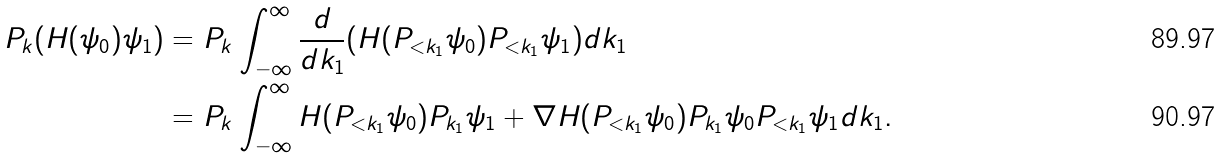<formula> <loc_0><loc_0><loc_500><loc_500>P _ { k } ( H ( \psi _ { 0 } ) \psi _ { 1 } ) = & \ P _ { k } \int _ { - \infty } ^ { \infty } \frac { d } { d k _ { 1 } } ( H ( P _ { < k _ { 1 } } \psi _ { 0 } ) P _ { < k _ { 1 } } \psi _ { 1 } ) d k _ { 1 } \\ = & \ P _ { k } \int _ { - \infty } ^ { \infty } H ( P _ { < k _ { 1 } } \psi _ { 0 } ) P _ { k _ { 1 } } \psi _ { 1 } + \nabla H ( P _ { < k _ { 1 } } \psi _ { 0 } ) P _ { k _ { 1 } } \psi _ { 0 } P _ { < k _ { 1 } } \psi _ { 1 } d k _ { 1 } .</formula> 